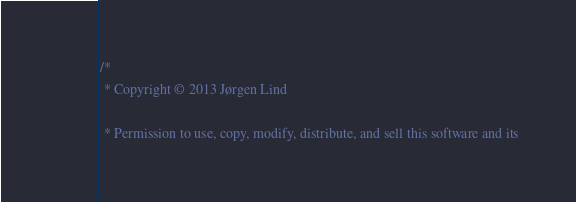Convert code to text. <code><loc_0><loc_0><loc_500><loc_500><_C++_>/*
 * Copyright © 2013 Jørgen Lind

 * Permission to use, copy, modify, distribute, and sell this software and its</code> 